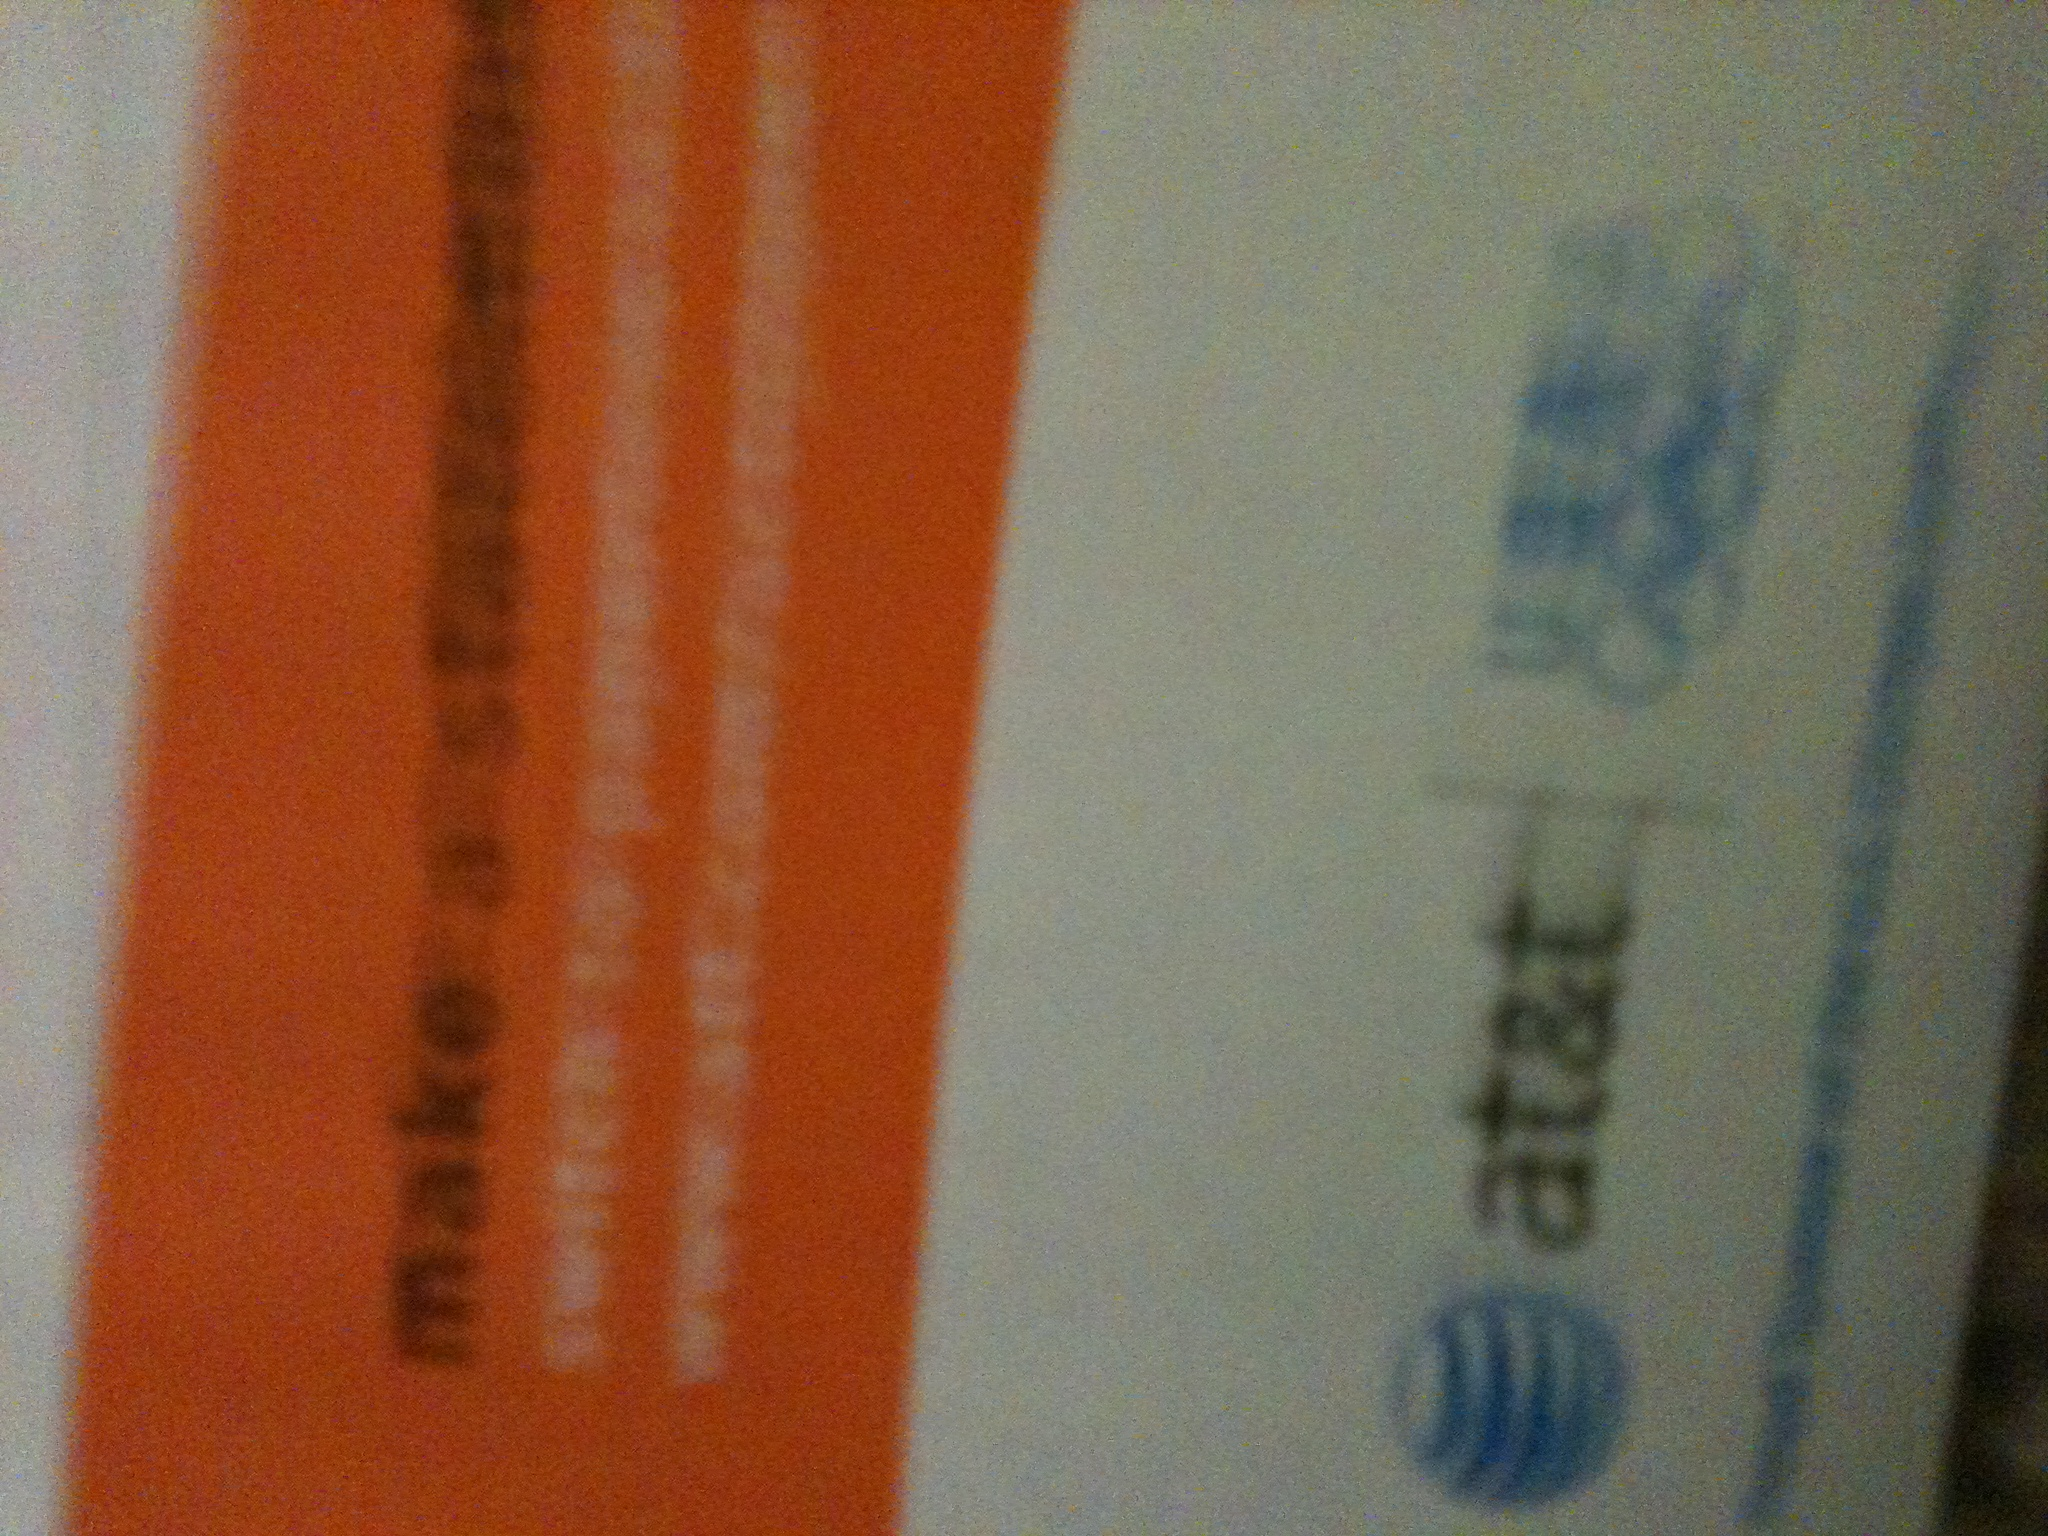is this piece of mail? Yes, this is a piece of mail. Specifically, it is an advertisement from AT&T. You can see the distinct orange header and the AT&T logo, which are typical in promotional mail from the company. 